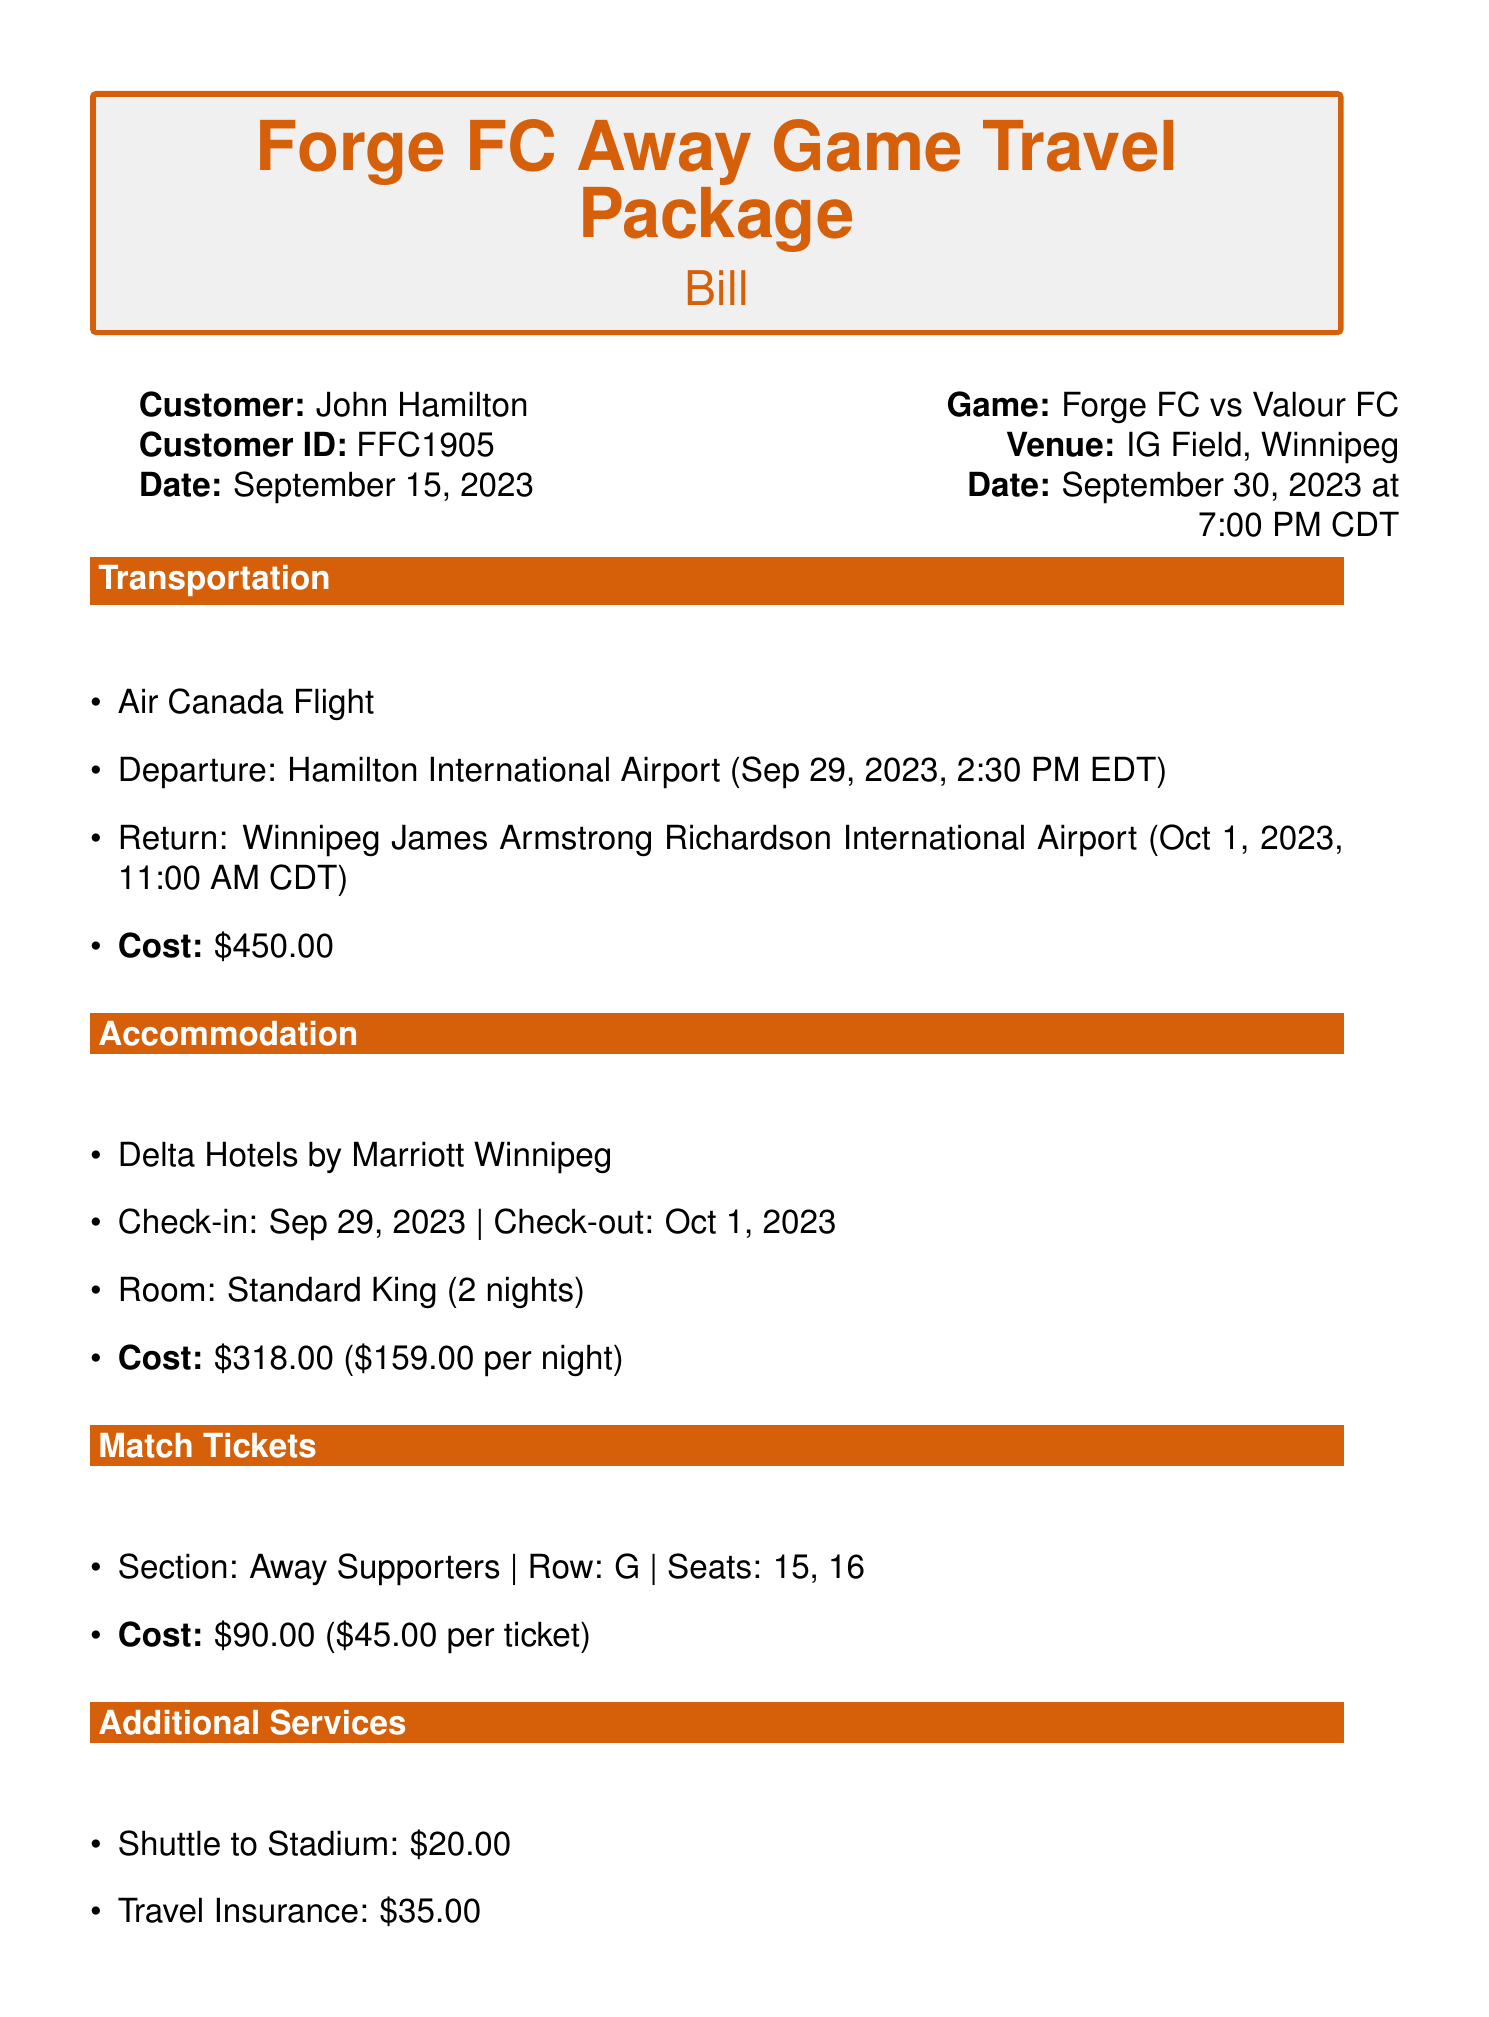What is the name of the customer? The name of the customer is listed at the beginning of the document.
Answer: John Hamilton What is the total cost of the travel package? The total cost is clearly mentioned in a specific section of the document.
Answer: $953.00 What is the departure airport? The airport of departure is provided in the transportation section of the bill.
Answer: Hamilton International Airport What is the date of the away game? The date of the game is specified in the game details section of the document.
Answer: September 30, 2023 How many nights is the accommodation booked for? The number of nights for the accommodation is indicated in the accommodation section.
Answer: 2 nights What is the cost of travel insurance? The cost of travel insurance is explicitly stated in the additional services section.
Answer: $35.00 In which section are the match tickets located? The section for the match tickets is detailed in a specific area of the document.
Answer: Away Supporters What time does the return flight depart? The departure time for the return flight is specified in the transportation section of the bill.
Answer: 11:00 AM CDT What is the payment method used? The payment method is listed towards the end of the document.
Answer: Visa ending in 4567 